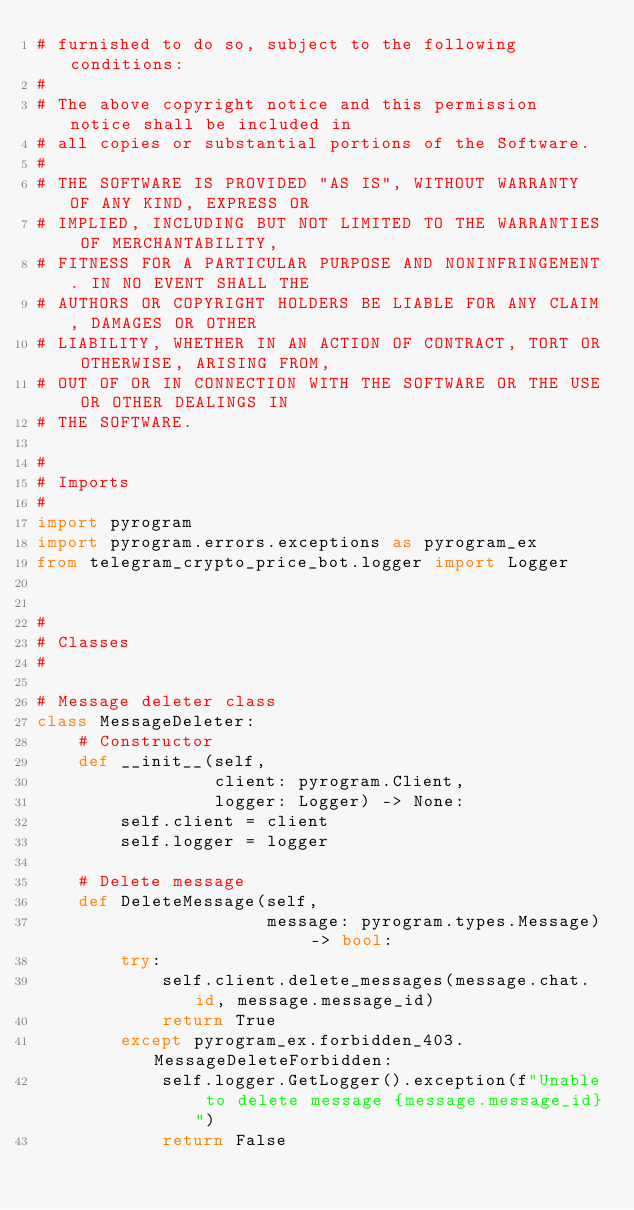Convert code to text. <code><loc_0><loc_0><loc_500><loc_500><_Python_># furnished to do so, subject to the following conditions:
#
# The above copyright notice and this permission notice shall be included in
# all copies or substantial portions of the Software.
#
# THE SOFTWARE IS PROVIDED "AS IS", WITHOUT WARRANTY OF ANY KIND, EXPRESS OR
# IMPLIED, INCLUDING BUT NOT LIMITED TO THE WARRANTIES OF MERCHANTABILITY,
# FITNESS FOR A PARTICULAR PURPOSE AND NONINFRINGEMENT. IN NO EVENT SHALL THE
# AUTHORS OR COPYRIGHT HOLDERS BE LIABLE FOR ANY CLAIM, DAMAGES OR OTHER
# LIABILITY, WHETHER IN AN ACTION OF CONTRACT, TORT OR OTHERWISE, ARISING FROM,
# OUT OF OR IN CONNECTION WITH THE SOFTWARE OR THE USE OR OTHER DEALINGS IN
# THE SOFTWARE.

#
# Imports
#
import pyrogram
import pyrogram.errors.exceptions as pyrogram_ex
from telegram_crypto_price_bot.logger import Logger


#
# Classes
#

# Message deleter class
class MessageDeleter:
    # Constructor
    def __init__(self,
                 client: pyrogram.Client,
                 logger: Logger) -> None:
        self.client = client
        self.logger = logger

    # Delete message
    def DeleteMessage(self,
                      message: pyrogram.types.Message) -> bool:
        try:
            self.client.delete_messages(message.chat.id, message.message_id)
            return True
        except pyrogram_ex.forbidden_403.MessageDeleteForbidden:
            self.logger.GetLogger().exception(f"Unable to delete message {message.message_id}")
            return False
</code> 